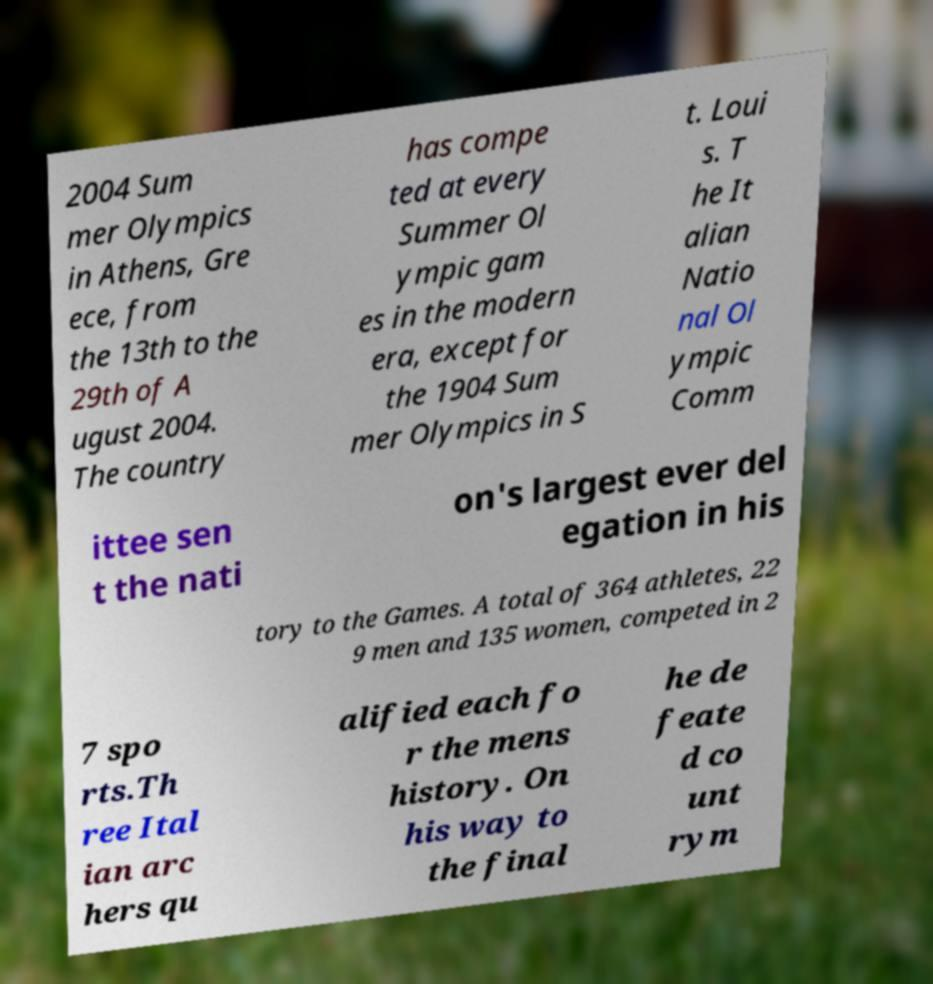Please identify and transcribe the text found in this image. 2004 Sum mer Olympics in Athens, Gre ece, from the 13th to the 29th of A ugust 2004. The country has compe ted at every Summer Ol ympic gam es in the modern era, except for the 1904 Sum mer Olympics in S t. Loui s. T he It alian Natio nal Ol ympic Comm ittee sen t the nati on's largest ever del egation in his tory to the Games. A total of 364 athletes, 22 9 men and 135 women, competed in 2 7 spo rts.Th ree Ital ian arc hers qu alified each fo r the mens history. On his way to the final he de feate d co unt rym 